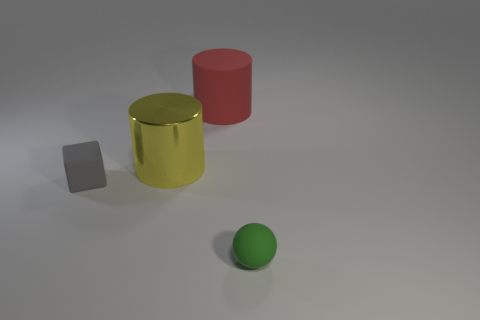Is there anything else that has the same material as the yellow thing?
Make the answer very short. No. There is a object that is the same size as the red matte cylinder; what shape is it?
Give a very brief answer. Cylinder. What number of objects are matte things that are on the right side of the tiny gray cube or metal cylinders?
Ensure brevity in your answer.  3. What is the size of the object in front of the tiny cube?
Offer a terse response. Small. Are there any other gray cubes of the same size as the matte cube?
Your answer should be compact. No. Is the size of the cylinder behind the metal thing the same as the yellow metal object?
Ensure brevity in your answer.  Yes. What size is the yellow cylinder?
Your answer should be compact. Large. There is a big cylinder that is left of the large cylinder that is behind the large object that is in front of the big red matte cylinder; what color is it?
Give a very brief answer. Yellow. How many rubber objects are both in front of the gray rubber block and left of the small green ball?
Offer a terse response. 0. There is a matte thing that is in front of the small rubber object that is on the left side of the green sphere; what number of tiny spheres are behind it?
Keep it short and to the point. 0. 